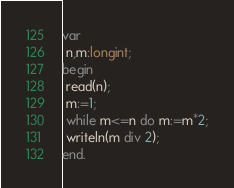<code> <loc_0><loc_0><loc_500><loc_500><_Pascal_>var
 n,m:longint;
begin
 read(n);
 m:=1;
 while m<=n do m:=m*2;
 writeln(m div 2);
end.</code> 